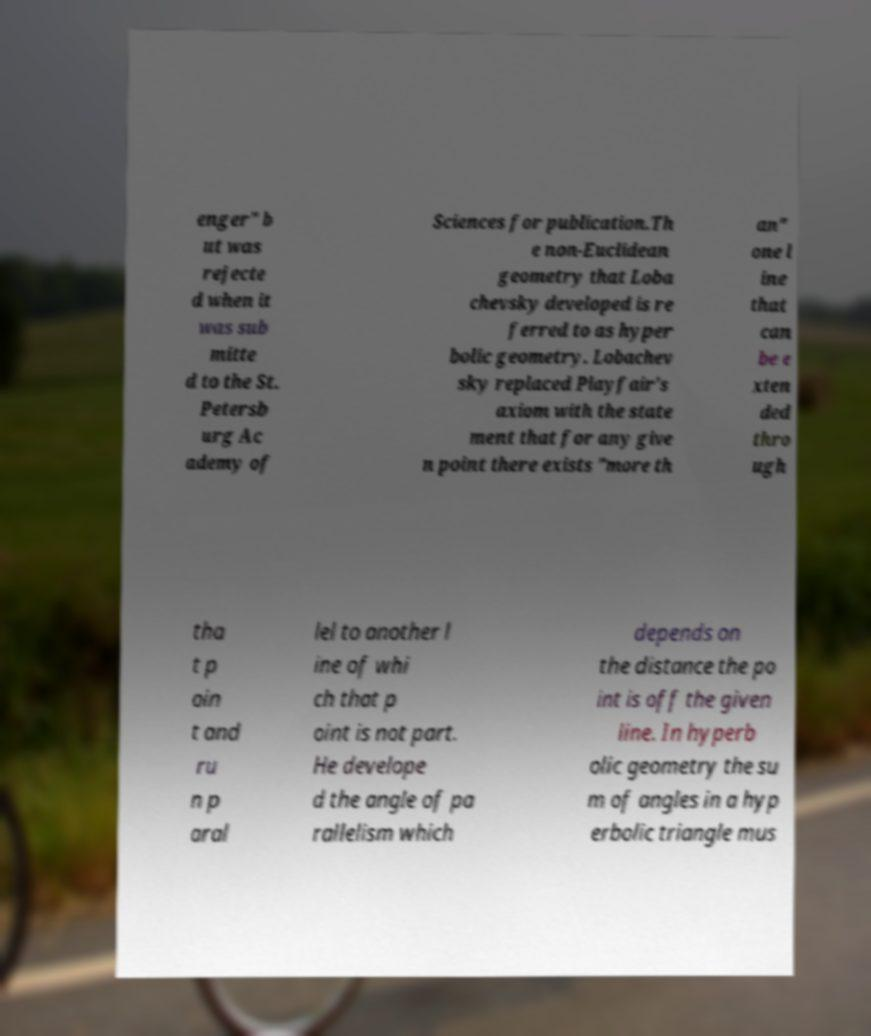Can you read and provide the text displayed in the image?This photo seems to have some interesting text. Can you extract and type it out for me? enger" b ut was rejecte d when it was sub mitte d to the St. Petersb urg Ac ademy of Sciences for publication.Th e non-Euclidean geometry that Loba chevsky developed is re ferred to as hyper bolic geometry. Lobachev sky replaced Playfair's axiom with the state ment that for any give n point there exists "more th an" one l ine that can be e xten ded thro ugh tha t p oin t and ru n p aral lel to another l ine of whi ch that p oint is not part. He develope d the angle of pa rallelism which depends on the distance the po int is off the given line. In hyperb olic geometry the su m of angles in a hyp erbolic triangle mus 